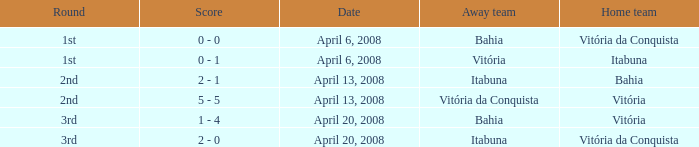Who was the home team on April 13, 2008 when Itabuna was the away team? Bahia. 